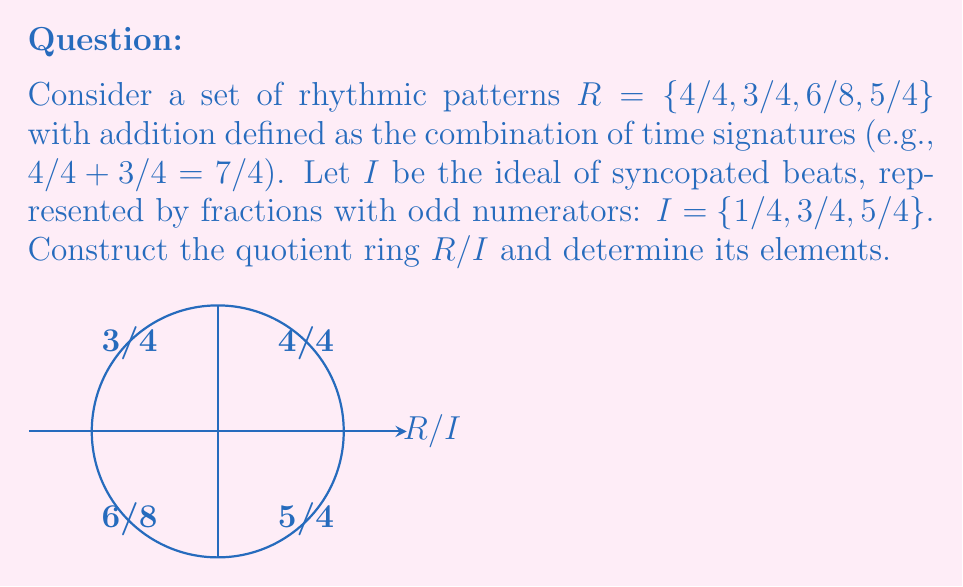Can you answer this question? To construct the quotient ring $R/I$, we need to follow these steps:

1) First, identify the elements of $R/I$. Each element in $R/I$ is a coset of the form $r + I$, where $r \in R$.

2) For each element in $R$, determine its coset:

   $4/4 + I = \{4/4 + i : i \in I\} = \{5/4, 7/4, 9/4\} \equiv 0/4 \pmod{I}$
   $3/4 + I = \{3/4 + i : i \in I\} = \{4/4, 6/4, 8/4\} \equiv 3/4 \pmod{I}$
   $6/8 + I = \{6/8 + i : i \in I\} = \{7/8, 9/8, 11/8\} \equiv 2/8 \pmod{I}$
   $5/4 + I = \{5/4 + i : i \in I\} = \{6/4, 8/4, 10/4\} \equiv 1/4 \pmod{I}$

3) Simplify the results:
   $0/4 \equiv 4/4 \pmod{I}$
   $3/4 \equiv 3/4 \pmod{I}$
   $2/8 \equiv 6/8 \pmod{I}$
   $1/4 \equiv 5/4 \pmod{I}$

4) Therefore, the elements of $R/I$ are:
   $\{[4/4], [3/4], [6/8], [5/4]\}$

Where $[x]$ denotes the coset containing $x$.

5) Note that $[3/4] = [5/4]$ because they differ by an element in $I$ (specifically, $1/4$).

Thus, the distinct elements of $R/I$ are $\{[4/4], [3/4], [6/8]\}$.
Answer: $R/I = \{[4/4], [3/4], [6/8]\}$ 